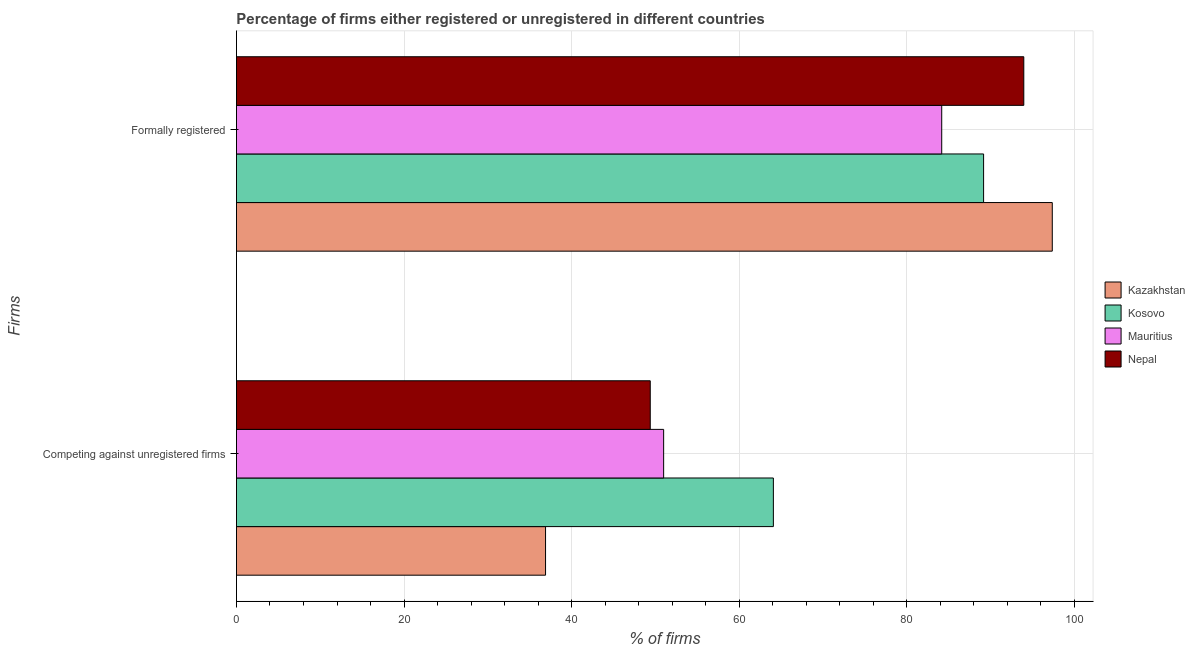How many different coloured bars are there?
Offer a terse response. 4. How many bars are there on the 1st tick from the top?
Provide a succinct answer. 4. What is the label of the 2nd group of bars from the top?
Your answer should be very brief. Competing against unregistered firms. What is the percentage of registered firms in Kazakhstan?
Your answer should be very brief. 36.9. Across all countries, what is the maximum percentage of registered firms?
Provide a short and direct response. 64.1. Across all countries, what is the minimum percentage of formally registered firms?
Give a very brief answer. 84.2. In which country was the percentage of formally registered firms maximum?
Provide a short and direct response. Kazakhstan. In which country was the percentage of registered firms minimum?
Offer a very short reply. Kazakhstan. What is the total percentage of formally registered firms in the graph?
Give a very brief answer. 364.8. What is the difference between the percentage of formally registered firms in Kazakhstan and that in Mauritius?
Your answer should be very brief. 13.2. What is the difference between the percentage of formally registered firms in Kosovo and the percentage of registered firms in Mauritius?
Your response must be concise. 38.2. What is the average percentage of registered firms per country?
Provide a succinct answer. 50.35. What is the difference between the percentage of formally registered firms and percentage of registered firms in Kazakhstan?
Keep it short and to the point. 60.5. In how many countries, is the percentage of formally registered firms greater than 40 %?
Provide a short and direct response. 4. What is the ratio of the percentage of registered firms in Nepal to that in Kazakhstan?
Offer a very short reply. 1.34. Is the percentage of formally registered firms in Kosovo less than that in Kazakhstan?
Provide a succinct answer. Yes. What does the 4th bar from the top in Competing against unregistered firms represents?
Your response must be concise. Kazakhstan. What does the 1st bar from the bottom in Competing against unregistered firms represents?
Your answer should be very brief. Kazakhstan. How many bars are there?
Offer a very short reply. 8. Are all the bars in the graph horizontal?
Make the answer very short. Yes. Are the values on the major ticks of X-axis written in scientific E-notation?
Make the answer very short. No. How are the legend labels stacked?
Your response must be concise. Vertical. What is the title of the graph?
Give a very brief answer. Percentage of firms either registered or unregistered in different countries. What is the label or title of the X-axis?
Offer a terse response. % of firms. What is the label or title of the Y-axis?
Make the answer very short. Firms. What is the % of firms of Kazakhstan in Competing against unregistered firms?
Your response must be concise. 36.9. What is the % of firms of Kosovo in Competing against unregistered firms?
Offer a very short reply. 64.1. What is the % of firms of Nepal in Competing against unregistered firms?
Provide a succinct answer. 49.4. What is the % of firms of Kazakhstan in Formally registered?
Keep it short and to the point. 97.4. What is the % of firms of Kosovo in Formally registered?
Make the answer very short. 89.2. What is the % of firms in Mauritius in Formally registered?
Your response must be concise. 84.2. What is the % of firms of Nepal in Formally registered?
Provide a short and direct response. 94. Across all Firms, what is the maximum % of firms of Kazakhstan?
Provide a short and direct response. 97.4. Across all Firms, what is the maximum % of firms of Kosovo?
Your response must be concise. 89.2. Across all Firms, what is the maximum % of firms of Mauritius?
Provide a short and direct response. 84.2. Across all Firms, what is the maximum % of firms of Nepal?
Offer a terse response. 94. Across all Firms, what is the minimum % of firms in Kazakhstan?
Keep it short and to the point. 36.9. Across all Firms, what is the minimum % of firms of Kosovo?
Offer a terse response. 64.1. Across all Firms, what is the minimum % of firms in Mauritius?
Your response must be concise. 51. Across all Firms, what is the minimum % of firms in Nepal?
Offer a terse response. 49.4. What is the total % of firms of Kazakhstan in the graph?
Your response must be concise. 134.3. What is the total % of firms in Kosovo in the graph?
Offer a very short reply. 153.3. What is the total % of firms of Mauritius in the graph?
Provide a succinct answer. 135.2. What is the total % of firms of Nepal in the graph?
Your answer should be very brief. 143.4. What is the difference between the % of firms of Kazakhstan in Competing against unregistered firms and that in Formally registered?
Your answer should be very brief. -60.5. What is the difference between the % of firms of Kosovo in Competing against unregistered firms and that in Formally registered?
Your answer should be very brief. -25.1. What is the difference between the % of firms in Mauritius in Competing against unregistered firms and that in Formally registered?
Provide a short and direct response. -33.2. What is the difference between the % of firms in Nepal in Competing against unregistered firms and that in Formally registered?
Offer a very short reply. -44.6. What is the difference between the % of firms of Kazakhstan in Competing against unregistered firms and the % of firms of Kosovo in Formally registered?
Provide a short and direct response. -52.3. What is the difference between the % of firms in Kazakhstan in Competing against unregistered firms and the % of firms in Mauritius in Formally registered?
Offer a very short reply. -47.3. What is the difference between the % of firms of Kazakhstan in Competing against unregistered firms and the % of firms of Nepal in Formally registered?
Provide a short and direct response. -57.1. What is the difference between the % of firms of Kosovo in Competing against unregistered firms and the % of firms of Mauritius in Formally registered?
Offer a terse response. -20.1. What is the difference between the % of firms in Kosovo in Competing against unregistered firms and the % of firms in Nepal in Formally registered?
Keep it short and to the point. -29.9. What is the difference between the % of firms in Mauritius in Competing against unregistered firms and the % of firms in Nepal in Formally registered?
Provide a short and direct response. -43. What is the average % of firms of Kazakhstan per Firms?
Your response must be concise. 67.15. What is the average % of firms in Kosovo per Firms?
Give a very brief answer. 76.65. What is the average % of firms in Mauritius per Firms?
Your answer should be compact. 67.6. What is the average % of firms in Nepal per Firms?
Ensure brevity in your answer.  71.7. What is the difference between the % of firms in Kazakhstan and % of firms in Kosovo in Competing against unregistered firms?
Keep it short and to the point. -27.2. What is the difference between the % of firms of Kazakhstan and % of firms of Mauritius in Competing against unregistered firms?
Keep it short and to the point. -14.1. What is the difference between the % of firms of Kazakhstan and % of firms of Nepal in Competing against unregistered firms?
Give a very brief answer. -12.5. What is the difference between the % of firms of Kosovo and % of firms of Mauritius in Competing against unregistered firms?
Make the answer very short. 13.1. What is the difference between the % of firms in Kosovo and % of firms in Nepal in Competing against unregistered firms?
Offer a very short reply. 14.7. What is the difference between the % of firms of Mauritius and % of firms of Nepal in Competing against unregistered firms?
Provide a succinct answer. 1.6. What is the difference between the % of firms in Kazakhstan and % of firms in Mauritius in Formally registered?
Your response must be concise. 13.2. What is the difference between the % of firms in Kazakhstan and % of firms in Nepal in Formally registered?
Make the answer very short. 3.4. What is the difference between the % of firms of Kosovo and % of firms of Mauritius in Formally registered?
Offer a very short reply. 5. What is the ratio of the % of firms in Kazakhstan in Competing against unregistered firms to that in Formally registered?
Offer a terse response. 0.38. What is the ratio of the % of firms of Kosovo in Competing against unregistered firms to that in Formally registered?
Ensure brevity in your answer.  0.72. What is the ratio of the % of firms in Mauritius in Competing against unregistered firms to that in Formally registered?
Provide a short and direct response. 0.61. What is the ratio of the % of firms of Nepal in Competing against unregistered firms to that in Formally registered?
Keep it short and to the point. 0.53. What is the difference between the highest and the second highest % of firms of Kazakhstan?
Give a very brief answer. 60.5. What is the difference between the highest and the second highest % of firms in Kosovo?
Your answer should be compact. 25.1. What is the difference between the highest and the second highest % of firms in Mauritius?
Provide a short and direct response. 33.2. What is the difference between the highest and the second highest % of firms in Nepal?
Provide a succinct answer. 44.6. What is the difference between the highest and the lowest % of firms in Kazakhstan?
Ensure brevity in your answer.  60.5. What is the difference between the highest and the lowest % of firms of Kosovo?
Offer a terse response. 25.1. What is the difference between the highest and the lowest % of firms in Mauritius?
Keep it short and to the point. 33.2. What is the difference between the highest and the lowest % of firms in Nepal?
Offer a very short reply. 44.6. 